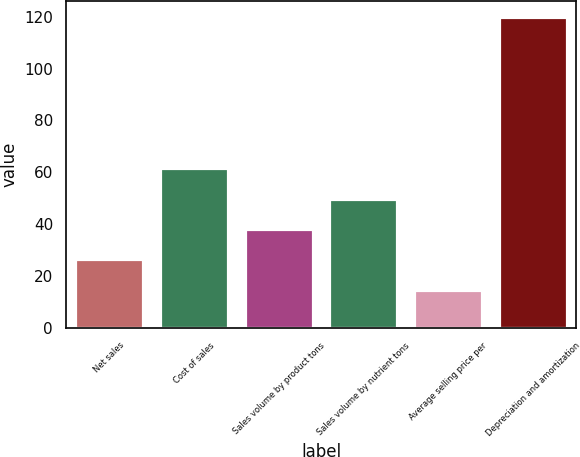<chart> <loc_0><loc_0><loc_500><loc_500><bar_chart><fcel>Net sales<fcel>Cost of sales<fcel>Sales volume by product tons<fcel>Sales volume by nutrient tons<fcel>Average selling price per<fcel>Depreciation and amortization<nl><fcel>26.4<fcel>61.5<fcel>38.1<fcel>49.8<fcel>14.7<fcel>120<nl></chart> 